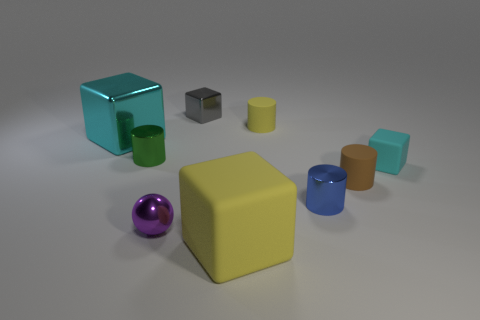Is there any other thing that has the same shape as the purple object?
Provide a short and direct response. No. What number of tiny gray objects are there?
Give a very brief answer. 1. What number of rubber objects are yellow cylinders or tiny things?
Your answer should be very brief. 3. What number of large metallic cubes have the same color as the small rubber block?
Offer a very short reply. 1. The yellow object that is in front of the big cube left of the small gray cube is made of what material?
Make the answer very short. Rubber. The brown matte cylinder is what size?
Provide a short and direct response. Small. How many metal blocks have the same size as the yellow matte cube?
Ensure brevity in your answer.  1. What number of other big objects are the same shape as the cyan matte thing?
Offer a terse response. 2. Is the number of small gray cubes that are behind the shiny sphere the same as the number of yellow rubber cubes?
Provide a short and direct response. Yes. Are there any other things that are the same size as the cyan rubber object?
Offer a terse response. Yes. 